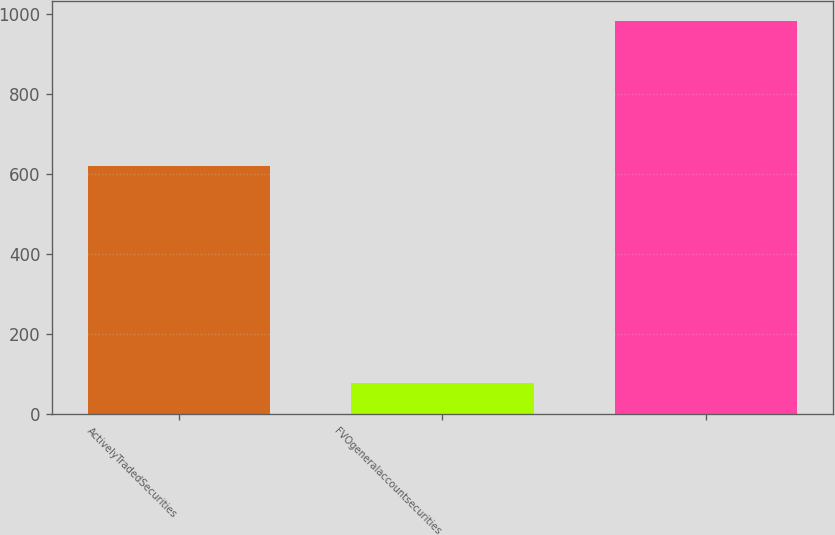Convert chart to OTSL. <chart><loc_0><loc_0><loc_500><loc_500><bar_chart><fcel>ActivelyTradedSecurities<fcel>FVOgeneralaccountsecurities<fcel>Unnamed: 2<nl><fcel>620.4<fcel>78<fcel>982<nl></chart> 